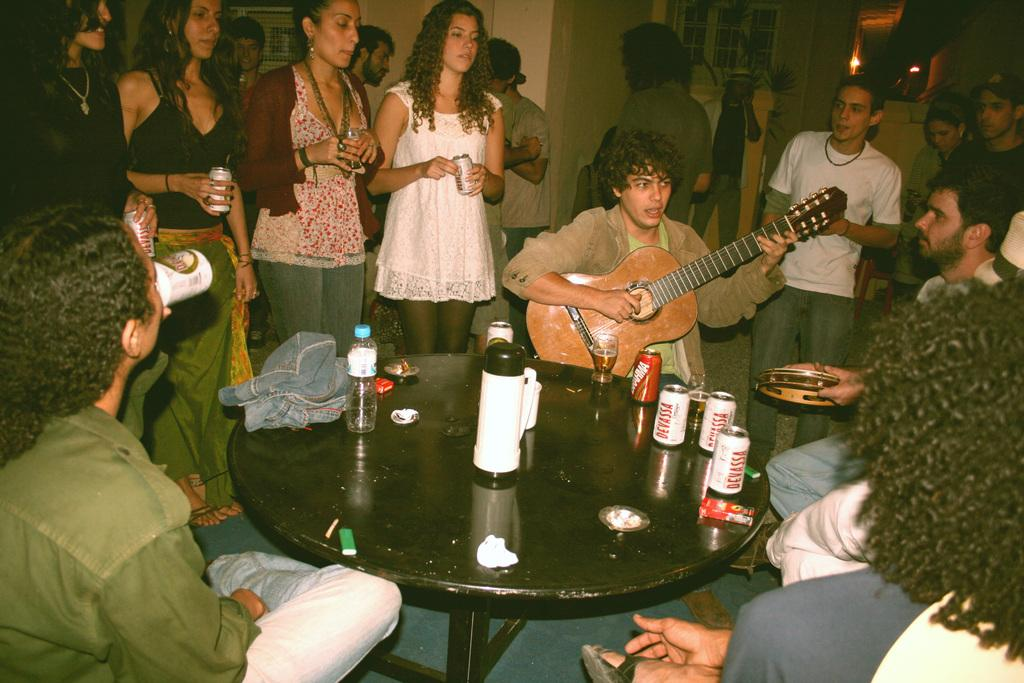How many people are in the image? There is a group of people in the image. What are some of the people doing in the image? Some people are standing, and some people are sitting on chairs. What is on the table in the image? There are tins and a jacket on the table. What type of face can be seen on the jacket in the image? There is no face present on the jacket in the image. How does the group of people react to a joke in the image? The image does not depict a joke or any reaction to it, so we cannot determine how the group of people might react. 